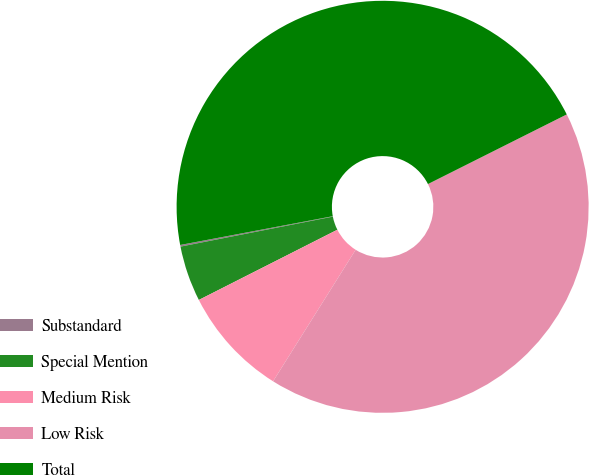Convert chart. <chart><loc_0><loc_0><loc_500><loc_500><pie_chart><fcel>Substandard<fcel>Special Mention<fcel>Medium Risk<fcel>Low Risk<fcel>Total<nl><fcel>0.13%<fcel>4.37%<fcel>8.61%<fcel>41.32%<fcel>45.56%<nl></chart> 